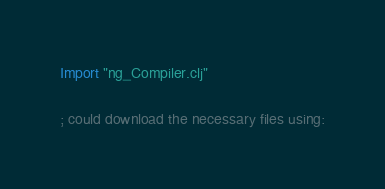Convert code to text. <code><loc_0><loc_0><loc_500><loc_500><_Clojure_>
Import "ng_Compiler.clj"

; could download the necessary files using:</code> 